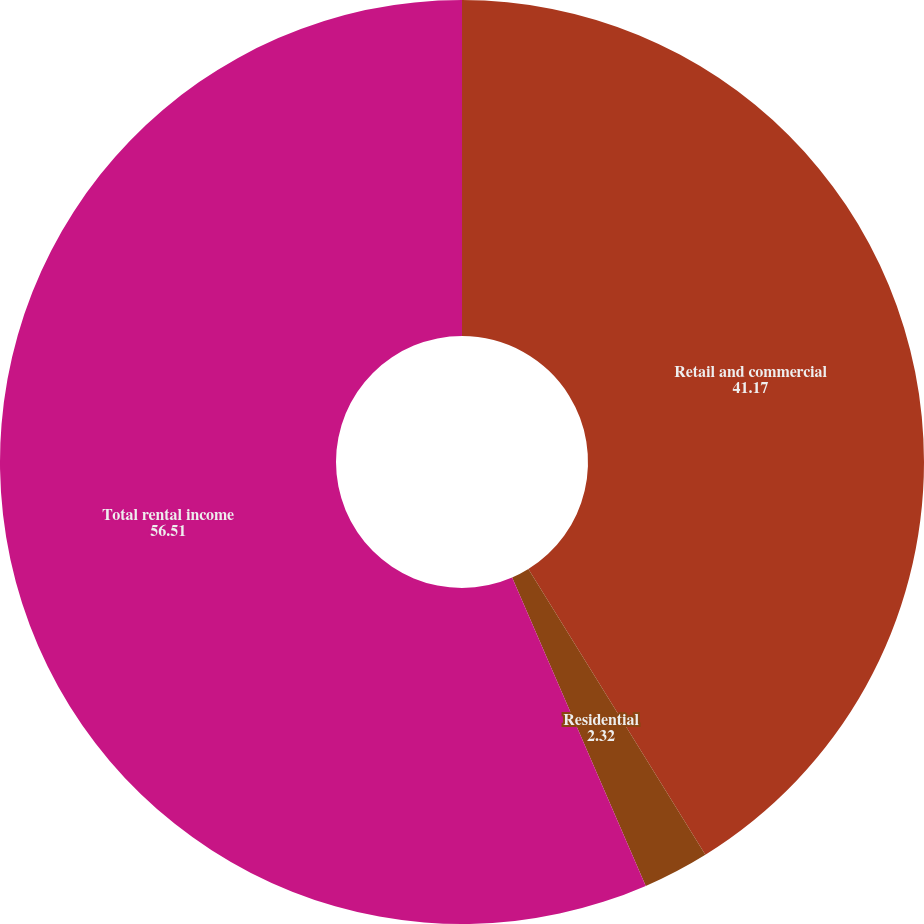Convert chart. <chart><loc_0><loc_0><loc_500><loc_500><pie_chart><fcel>Retail and commercial<fcel>Residential<fcel>Total rental income<nl><fcel>41.17%<fcel>2.32%<fcel>56.51%<nl></chart> 